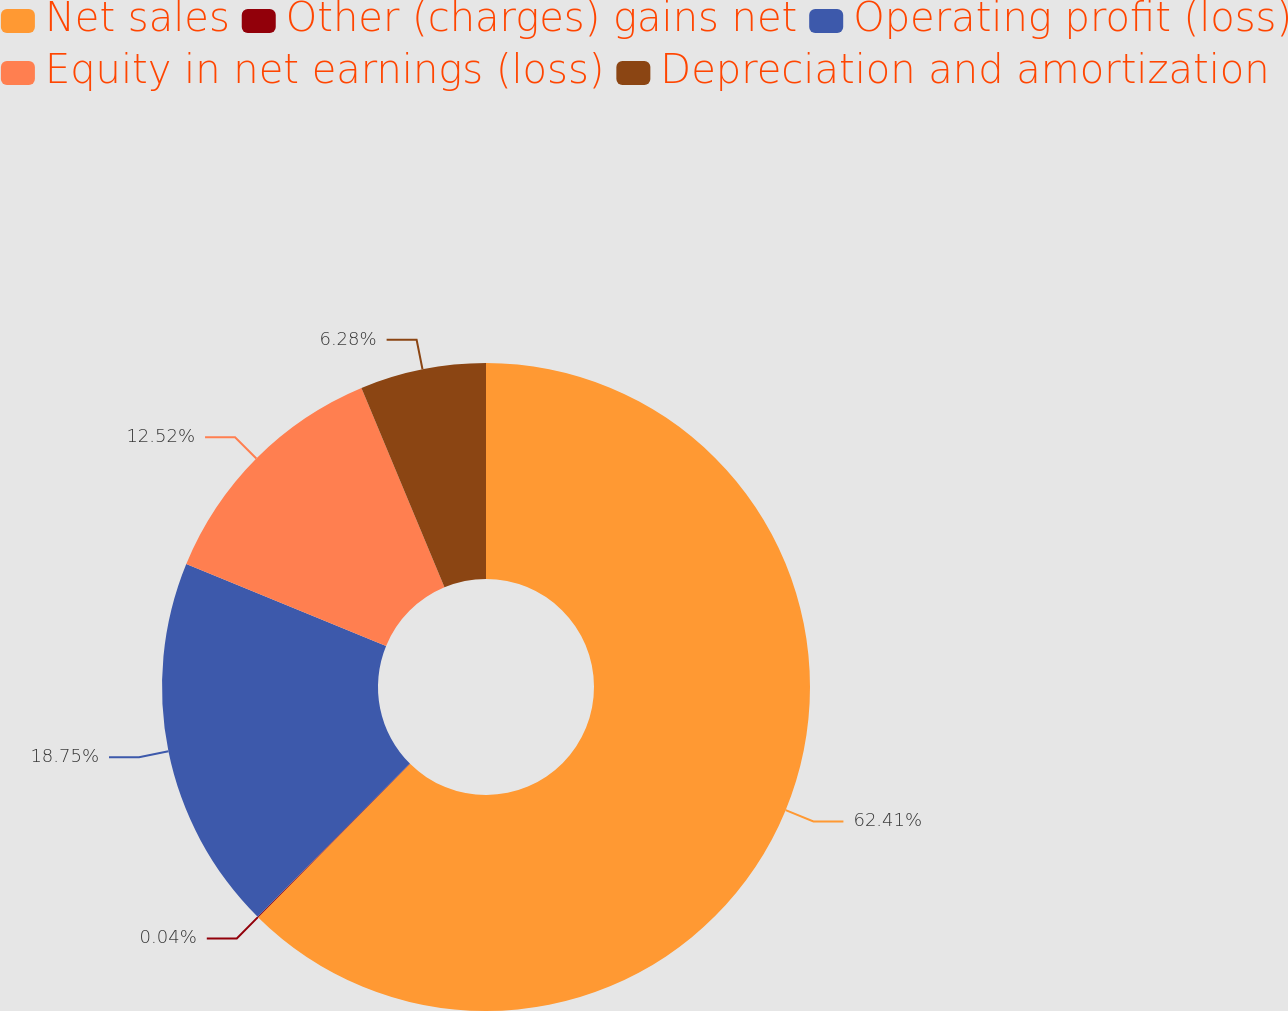Convert chart to OTSL. <chart><loc_0><loc_0><loc_500><loc_500><pie_chart><fcel>Net sales<fcel>Other (charges) gains net<fcel>Operating profit (loss)<fcel>Equity in net earnings (loss)<fcel>Depreciation and amortization<nl><fcel>62.41%<fcel>0.04%<fcel>18.75%<fcel>12.52%<fcel>6.28%<nl></chart> 